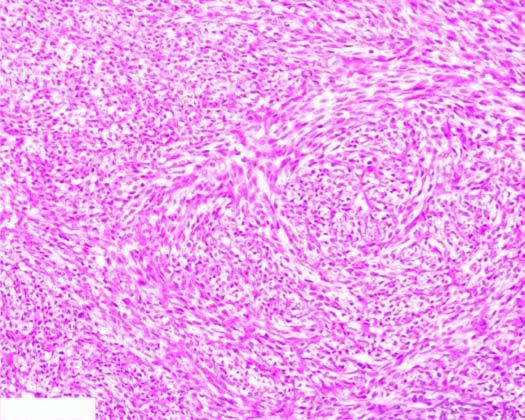what are arranged in storiform or cartwheel pattern?
Answer the question using a single word or phrase. Tumour cells 